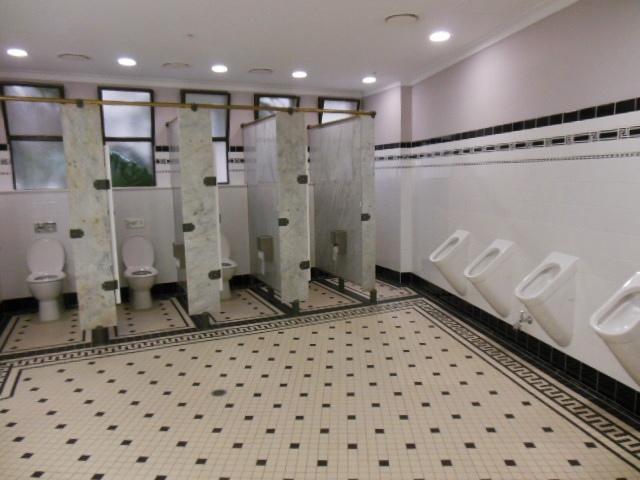What type of location is this?
Choose the right answer from the provided options to respond to the question.
Options: Residential, public, private, theatrical. Public. 